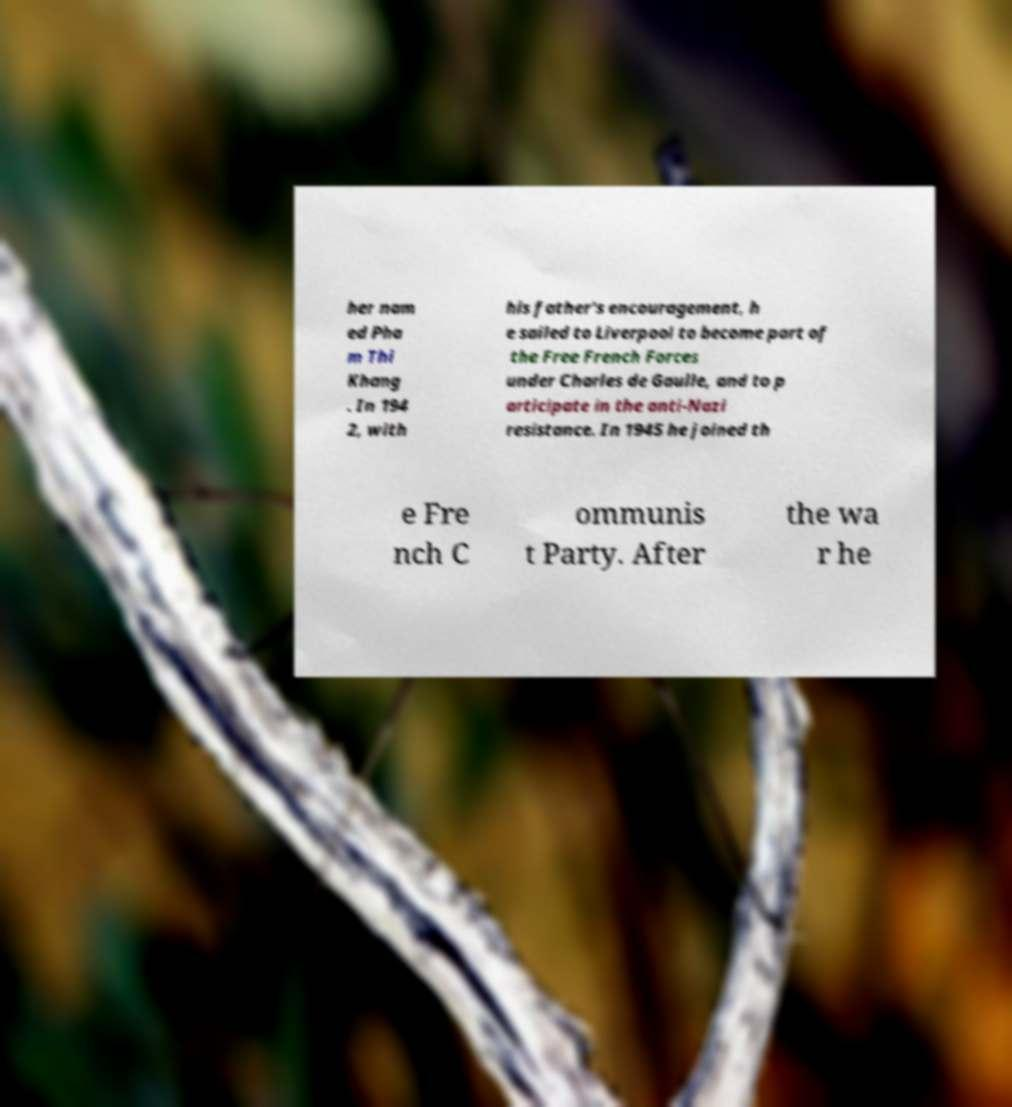Please read and relay the text visible in this image. What does it say? her nam ed Pha m Thi Khang . In 194 2, with his father's encouragement, h e sailed to Liverpool to become part of the Free French Forces under Charles de Gaulle, and to p articipate in the anti-Nazi resistance. In 1945 he joined th e Fre nch C ommunis t Party. After the wa r he 